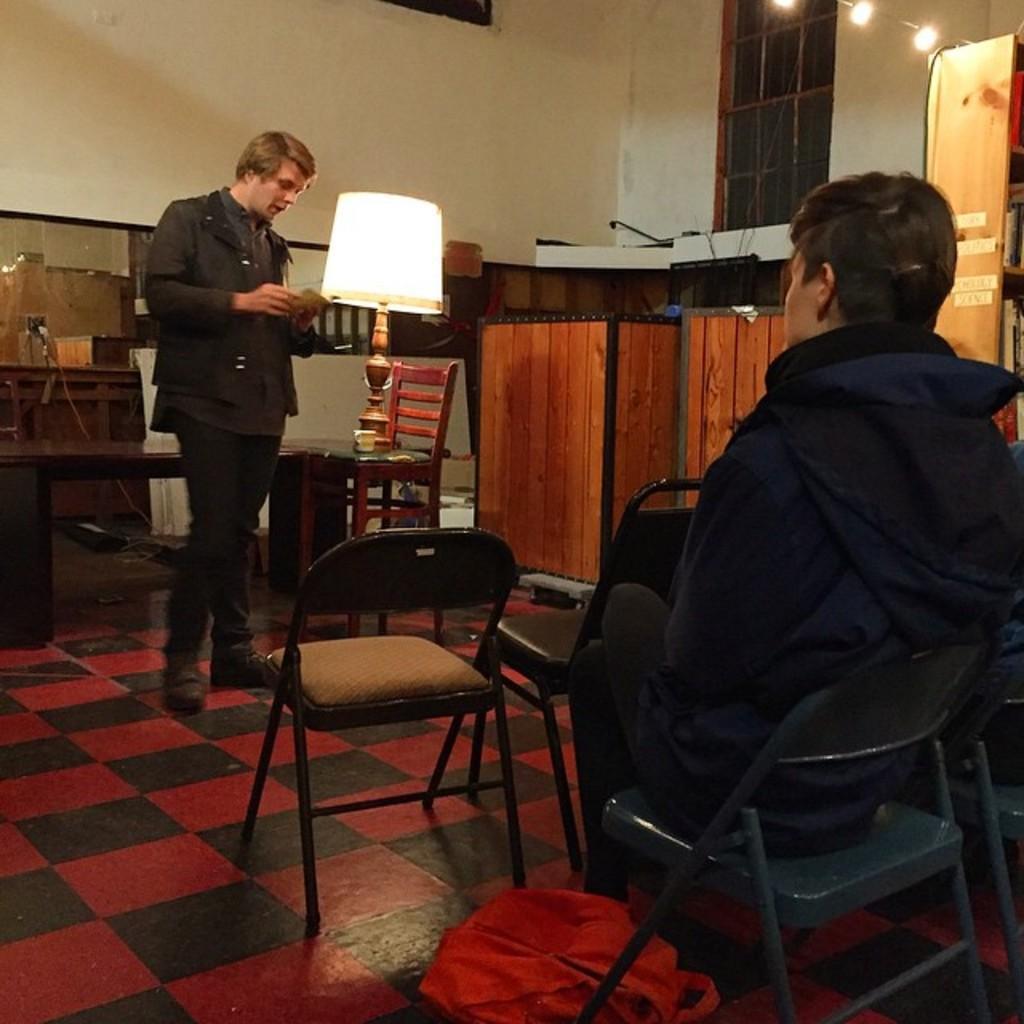Can you describe this image briefly? The person in the right is sitting in chair and there is another person standing in front of him and looking in to a book and there is a lamp beside him. 